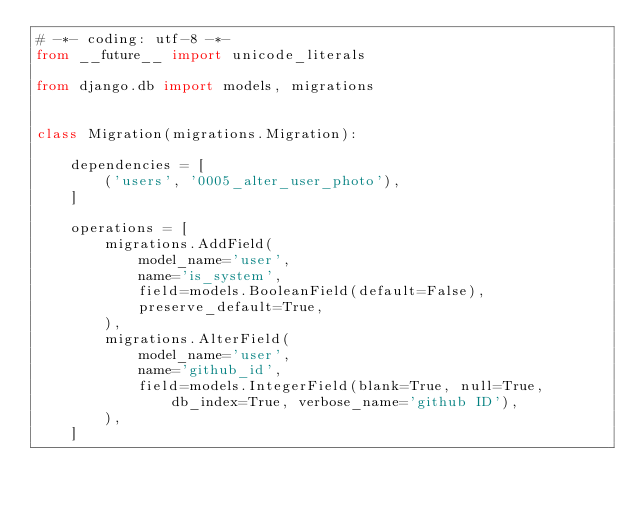Convert code to text. <code><loc_0><loc_0><loc_500><loc_500><_Python_># -*- coding: utf-8 -*-
from __future__ import unicode_literals

from django.db import models, migrations


class Migration(migrations.Migration):

    dependencies = [
        ('users', '0005_alter_user_photo'),
    ]

    operations = [
        migrations.AddField(
            model_name='user',
            name='is_system',
            field=models.BooleanField(default=False),
            preserve_default=True,
        ),
        migrations.AlterField(
            model_name='user',
            name='github_id',
            field=models.IntegerField(blank=True, null=True, db_index=True, verbose_name='github ID'),
        ),
    ]
</code> 